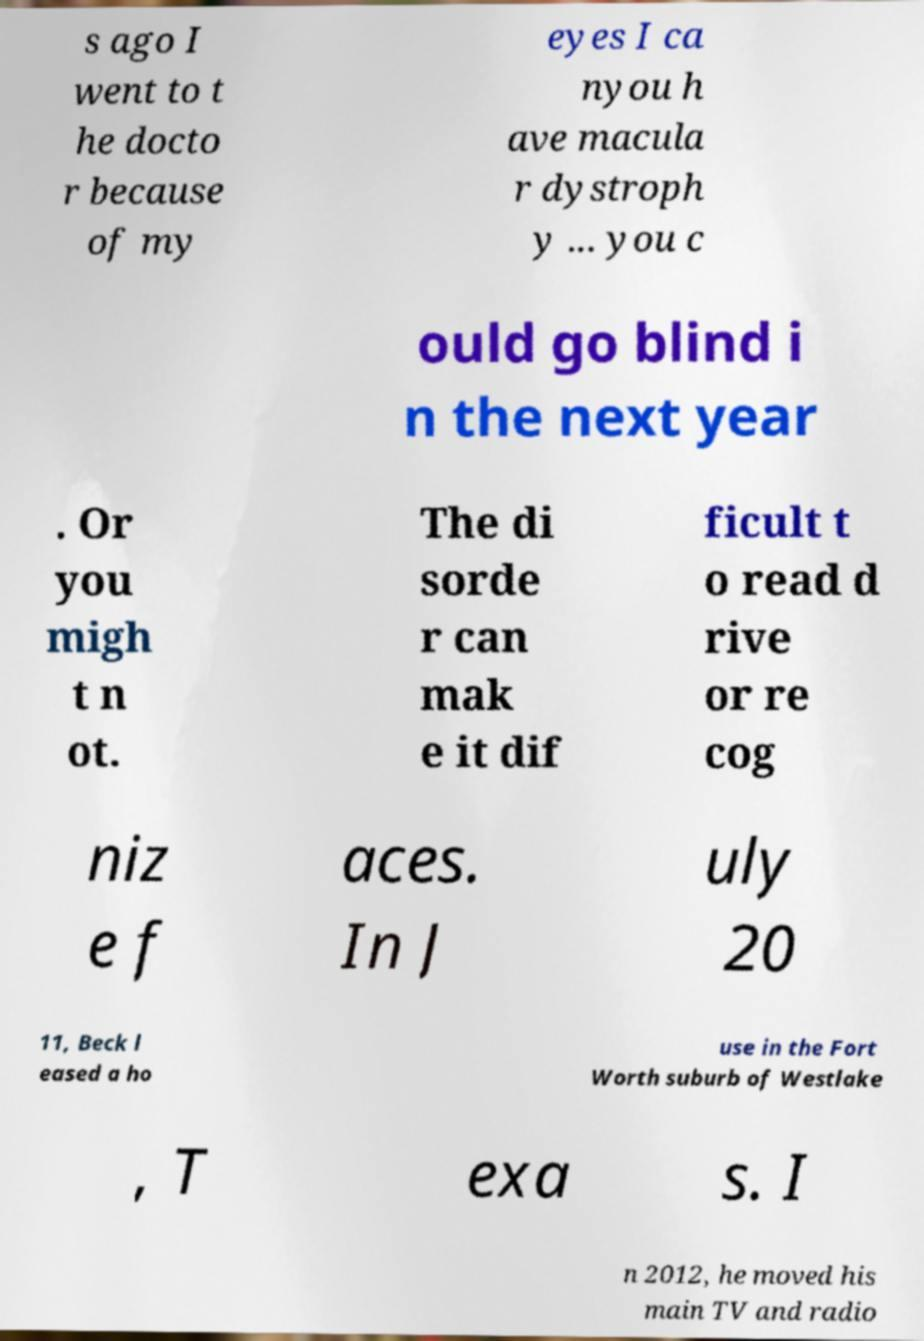There's text embedded in this image that I need extracted. Can you transcribe it verbatim? s ago I went to t he docto r because of my eyes I ca nyou h ave macula r dystroph y ... you c ould go blind i n the next year . Or you migh t n ot. The di sorde r can mak e it dif ficult t o read d rive or re cog niz e f aces. In J uly 20 11, Beck l eased a ho use in the Fort Worth suburb of Westlake , T exa s. I n 2012, he moved his main TV and radio 